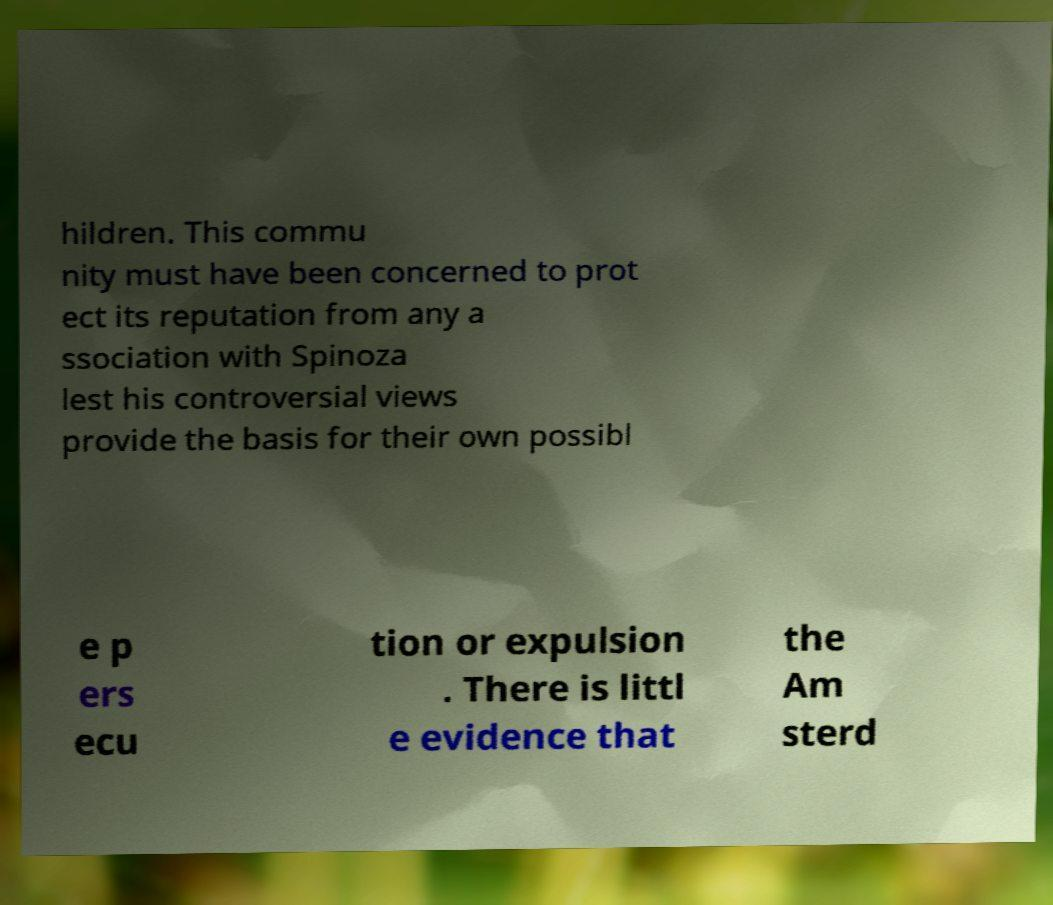For documentation purposes, I need the text within this image transcribed. Could you provide that? hildren. This commu nity must have been concerned to prot ect its reputation from any a ssociation with Spinoza lest his controversial views provide the basis for their own possibl e p ers ecu tion or expulsion . There is littl e evidence that the Am sterd 